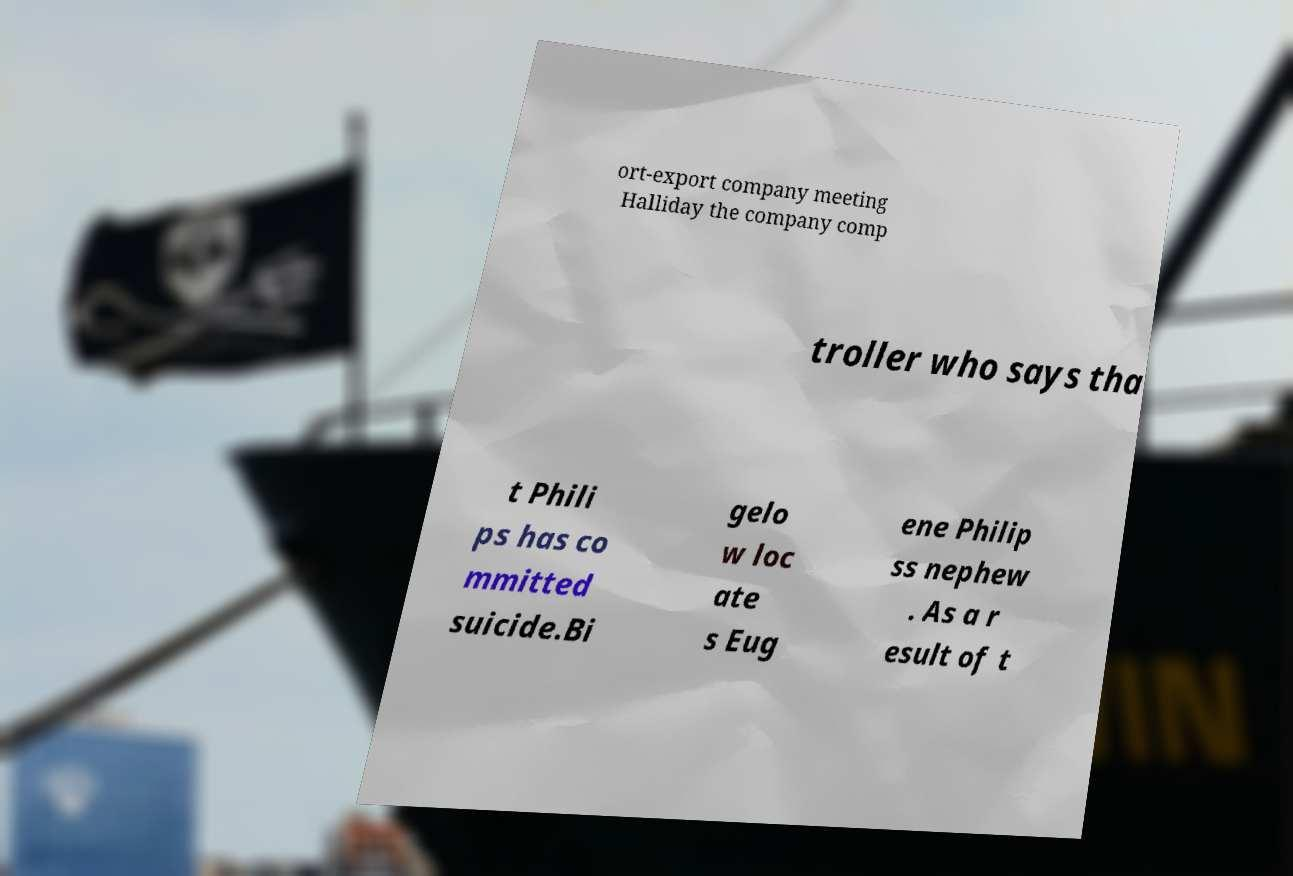Please read and relay the text visible in this image. What does it say? ort-export company meeting Halliday the company comp troller who says tha t Phili ps has co mmitted suicide.Bi gelo w loc ate s Eug ene Philip ss nephew . As a r esult of t 